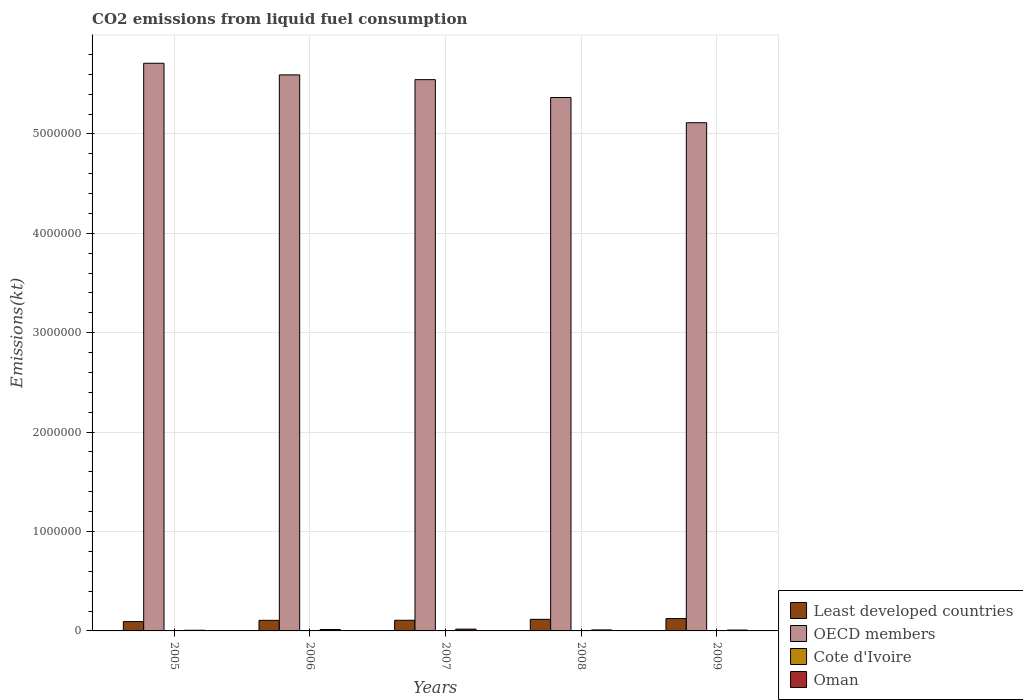How many different coloured bars are there?
Ensure brevity in your answer.  4. How many groups of bars are there?
Your answer should be very brief. 5. How many bars are there on the 4th tick from the left?
Your answer should be very brief. 4. What is the label of the 2nd group of bars from the left?
Give a very brief answer. 2006. What is the amount of CO2 emitted in OECD members in 2009?
Your answer should be very brief. 5.11e+06. Across all years, what is the maximum amount of CO2 emitted in Least developed countries?
Provide a short and direct response. 1.24e+05. Across all years, what is the minimum amount of CO2 emitted in OECD members?
Provide a succinct answer. 5.11e+06. In which year was the amount of CO2 emitted in OECD members maximum?
Provide a succinct answer. 2005. What is the total amount of CO2 emitted in Cote d'Ivoire in the graph?
Provide a short and direct response. 1.82e+04. What is the difference between the amount of CO2 emitted in Cote d'Ivoire in 2005 and that in 2008?
Your answer should be compact. 517.05. What is the difference between the amount of CO2 emitted in Cote d'Ivoire in 2008 and the amount of CO2 emitted in Least developed countries in 2009?
Offer a terse response. -1.20e+05. What is the average amount of CO2 emitted in Least developed countries per year?
Your answer should be compact. 1.10e+05. In the year 2005, what is the difference between the amount of CO2 emitted in Cote d'Ivoire and amount of CO2 emitted in OECD members?
Offer a very short reply. -5.71e+06. In how many years, is the amount of CO2 emitted in Least developed countries greater than 4400000 kt?
Ensure brevity in your answer.  0. What is the ratio of the amount of CO2 emitted in OECD members in 2008 to that in 2009?
Give a very brief answer. 1.05. What is the difference between the highest and the second highest amount of CO2 emitted in Oman?
Give a very brief answer. 4176.71. What is the difference between the highest and the lowest amount of CO2 emitted in Least developed countries?
Offer a very short reply. 3.02e+04. In how many years, is the amount of CO2 emitted in Oman greater than the average amount of CO2 emitted in Oman taken over all years?
Provide a short and direct response. 2. What does the 3rd bar from the left in 2009 represents?
Provide a succinct answer. Cote d'Ivoire. What does the 3rd bar from the right in 2005 represents?
Make the answer very short. OECD members. Are all the bars in the graph horizontal?
Your response must be concise. No. What is the difference between two consecutive major ticks on the Y-axis?
Offer a terse response. 1.00e+06. Are the values on the major ticks of Y-axis written in scientific E-notation?
Provide a short and direct response. No. Where does the legend appear in the graph?
Your answer should be compact. Bottom right. What is the title of the graph?
Keep it short and to the point. CO2 emissions from liquid fuel consumption. Does "Togo" appear as one of the legend labels in the graph?
Keep it short and to the point. No. What is the label or title of the Y-axis?
Provide a short and direct response. Emissions(kt). What is the Emissions(kt) in Least developed countries in 2005?
Provide a succinct answer. 9.39e+04. What is the Emissions(kt) in OECD members in 2005?
Provide a short and direct response. 5.71e+06. What is the Emissions(kt) of Cote d'Ivoire in 2005?
Provide a short and direct response. 4165.71. What is the Emissions(kt) in Oman in 2005?
Your response must be concise. 6875.62. What is the Emissions(kt) in Least developed countries in 2006?
Your response must be concise. 1.06e+05. What is the Emissions(kt) of OECD members in 2006?
Give a very brief answer. 5.59e+06. What is the Emissions(kt) of Cote d'Ivoire in 2006?
Your answer should be compact. 3681.67. What is the Emissions(kt) of Oman in 2006?
Make the answer very short. 1.40e+04. What is the Emissions(kt) of Least developed countries in 2007?
Your answer should be very brief. 1.07e+05. What is the Emissions(kt) in OECD members in 2007?
Provide a short and direct response. 5.55e+06. What is the Emissions(kt) in Cote d'Ivoire in 2007?
Your response must be concise. 3758.68. What is the Emissions(kt) of Oman in 2007?
Make the answer very short. 1.82e+04. What is the Emissions(kt) in Least developed countries in 2008?
Give a very brief answer. 1.16e+05. What is the Emissions(kt) of OECD members in 2008?
Provide a short and direct response. 5.37e+06. What is the Emissions(kt) in Cote d'Ivoire in 2008?
Provide a short and direct response. 3648.66. What is the Emissions(kt) in Oman in 2008?
Provide a succinct answer. 9933.9. What is the Emissions(kt) of Least developed countries in 2009?
Provide a succinct answer. 1.24e+05. What is the Emissions(kt) of OECD members in 2009?
Make the answer very short. 5.11e+06. What is the Emissions(kt) in Cote d'Ivoire in 2009?
Your answer should be very brief. 2929.93. What is the Emissions(kt) in Oman in 2009?
Provide a short and direct response. 8742.13. Across all years, what is the maximum Emissions(kt) in Least developed countries?
Ensure brevity in your answer.  1.24e+05. Across all years, what is the maximum Emissions(kt) of OECD members?
Keep it short and to the point. 5.71e+06. Across all years, what is the maximum Emissions(kt) in Cote d'Ivoire?
Ensure brevity in your answer.  4165.71. Across all years, what is the maximum Emissions(kt) in Oman?
Give a very brief answer. 1.82e+04. Across all years, what is the minimum Emissions(kt) in Least developed countries?
Give a very brief answer. 9.39e+04. Across all years, what is the minimum Emissions(kt) of OECD members?
Your answer should be compact. 5.11e+06. Across all years, what is the minimum Emissions(kt) of Cote d'Ivoire?
Give a very brief answer. 2929.93. Across all years, what is the minimum Emissions(kt) of Oman?
Ensure brevity in your answer.  6875.62. What is the total Emissions(kt) of Least developed countries in the graph?
Give a very brief answer. 5.48e+05. What is the total Emissions(kt) in OECD members in the graph?
Offer a very short reply. 2.73e+07. What is the total Emissions(kt) in Cote d'Ivoire in the graph?
Your answer should be compact. 1.82e+04. What is the total Emissions(kt) in Oman in the graph?
Make the answer very short. 5.78e+04. What is the difference between the Emissions(kt) in Least developed countries in 2005 and that in 2006?
Provide a short and direct response. -1.26e+04. What is the difference between the Emissions(kt) in OECD members in 2005 and that in 2006?
Provide a short and direct response. 1.17e+05. What is the difference between the Emissions(kt) of Cote d'Ivoire in 2005 and that in 2006?
Make the answer very short. 484.04. What is the difference between the Emissions(kt) of Oman in 2005 and that in 2006?
Your answer should be very brief. -7165.32. What is the difference between the Emissions(kt) in Least developed countries in 2005 and that in 2007?
Provide a short and direct response. -1.33e+04. What is the difference between the Emissions(kt) in OECD members in 2005 and that in 2007?
Make the answer very short. 1.65e+05. What is the difference between the Emissions(kt) of Cote d'Ivoire in 2005 and that in 2007?
Offer a very short reply. 407.04. What is the difference between the Emissions(kt) in Oman in 2005 and that in 2007?
Your answer should be very brief. -1.13e+04. What is the difference between the Emissions(kt) in Least developed countries in 2005 and that in 2008?
Offer a very short reply. -2.26e+04. What is the difference between the Emissions(kt) of OECD members in 2005 and that in 2008?
Ensure brevity in your answer.  3.45e+05. What is the difference between the Emissions(kt) of Cote d'Ivoire in 2005 and that in 2008?
Provide a succinct answer. 517.05. What is the difference between the Emissions(kt) of Oman in 2005 and that in 2008?
Provide a short and direct response. -3058.28. What is the difference between the Emissions(kt) in Least developed countries in 2005 and that in 2009?
Offer a very short reply. -3.02e+04. What is the difference between the Emissions(kt) in OECD members in 2005 and that in 2009?
Your answer should be very brief. 5.98e+05. What is the difference between the Emissions(kt) in Cote d'Ivoire in 2005 and that in 2009?
Provide a short and direct response. 1235.78. What is the difference between the Emissions(kt) in Oman in 2005 and that in 2009?
Provide a short and direct response. -1866.5. What is the difference between the Emissions(kt) in Least developed countries in 2006 and that in 2007?
Give a very brief answer. -741.75. What is the difference between the Emissions(kt) of OECD members in 2006 and that in 2007?
Provide a succinct answer. 4.79e+04. What is the difference between the Emissions(kt) of Cote d'Ivoire in 2006 and that in 2007?
Offer a terse response. -77.01. What is the difference between the Emissions(kt) of Oman in 2006 and that in 2007?
Offer a terse response. -4176.71. What is the difference between the Emissions(kt) in Least developed countries in 2006 and that in 2008?
Offer a very short reply. -1.00e+04. What is the difference between the Emissions(kt) in OECD members in 2006 and that in 2008?
Keep it short and to the point. 2.28e+05. What is the difference between the Emissions(kt) of Cote d'Ivoire in 2006 and that in 2008?
Provide a succinct answer. 33. What is the difference between the Emissions(kt) in Oman in 2006 and that in 2008?
Give a very brief answer. 4107.04. What is the difference between the Emissions(kt) of Least developed countries in 2006 and that in 2009?
Offer a terse response. -1.76e+04. What is the difference between the Emissions(kt) in OECD members in 2006 and that in 2009?
Your response must be concise. 4.81e+05. What is the difference between the Emissions(kt) of Cote d'Ivoire in 2006 and that in 2009?
Offer a very short reply. 751.74. What is the difference between the Emissions(kt) in Oman in 2006 and that in 2009?
Offer a terse response. 5298.81. What is the difference between the Emissions(kt) in Least developed countries in 2007 and that in 2008?
Your answer should be very brief. -9295.17. What is the difference between the Emissions(kt) of OECD members in 2007 and that in 2008?
Keep it short and to the point. 1.80e+05. What is the difference between the Emissions(kt) of Cote d'Ivoire in 2007 and that in 2008?
Make the answer very short. 110.01. What is the difference between the Emissions(kt) of Oman in 2007 and that in 2008?
Your answer should be compact. 8283.75. What is the difference between the Emissions(kt) in Least developed countries in 2007 and that in 2009?
Offer a terse response. -1.69e+04. What is the difference between the Emissions(kt) of OECD members in 2007 and that in 2009?
Your answer should be very brief. 4.33e+05. What is the difference between the Emissions(kt) in Cote d'Ivoire in 2007 and that in 2009?
Your response must be concise. 828.74. What is the difference between the Emissions(kt) of Oman in 2007 and that in 2009?
Provide a short and direct response. 9475.53. What is the difference between the Emissions(kt) in Least developed countries in 2008 and that in 2009?
Provide a succinct answer. -7571.93. What is the difference between the Emissions(kt) of OECD members in 2008 and that in 2009?
Your response must be concise. 2.54e+05. What is the difference between the Emissions(kt) in Cote d'Ivoire in 2008 and that in 2009?
Give a very brief answer. 718.73. What is the difference between the Emissions(kt) of Oman in 2008 and that in 2009?
Your response must be concise. 1191.78. What is the difference between the Emissions(kt) in Least developed countries in 2005 and the Emissions(kt) in OECD members in 2006?
Offer a terse response. -5.50e+06. What is the difference between the Emissions(kt) of Least developed countries in 2005 and the Emissions(kt) of Cote d'Ivoire in 2006?
Your response must be concise. 9.02e+04. What is the difference between the Emissions(kt) in Least developed countries in 2005 and the Emissions(kt) in Oman in 2006?
Your answer should be compact. 7.98e+04. What is the difference between the Emissions(kt) of OECD members in 2005 and the Emissions(kt) of Cote d'Ivoire in 2006?
Keep it short and to the point. 5.71e+06. What is the difference between the Emissions(kt) of OECD members in 2005 and the Emissions(kt) of Oman in 2006?
Provide a short and direct response. 5.70e+06. What is the difference between the Emissions(kt) of Cote d'Ivoire in 2005 and the Emissions(kt) of Oman in 2006?
Make the answer very short. -9875.23. What is the difference between the Emissions(kt) of Least developed countries in 2005 and the Emissions(kt) of OECD members in 2007?
Provide a short and direct response. -5.45e+06. What is the difference between the Emissions(kt) of Least developed countries in 2005 and the Emissions(kt) of Cote d'Ivoire in 2007?
Your answer should be very brief. 9.01e+04. What is the difference between the Emissions(kt) in Least developed countries in 2005 and the Emissions(kt) in Oman in 2007?
Give a very brief answer. 7.56e+04. What is the difference between the Emissions(kt) in OECD members in 2005 and the Emissions(kt) in Cote d'Ivoire in 2007?
Make the answer very short. 5.71e+06. What is the difference between the Emissions(kt) of OECD members in 2005 and the Emissions(kt) of Oman in 2007?
Make the answer very short. 5.69e+06. What is the difference between the Emissions(kt) of Cote d'Ivoire in 2005 and the Emissions(kt) of Oman in 2007?
Your response must be concise. -1.41e+04. What is the difference between the Emissions(kt) in Least developed countries in 2005 and the Emissions(kt) in OECD members in 2008?
Give a very brief answer. -5.27e+06. What is the difference between the Emissions(kt) in Least developed countries in 2005 and the Emissions(kt) in Cote d'Ivoire in 2008?
Provide a short and direct response. 9.02e+04. What is the difference between the Emissions(kt) of Least developed countries in 2005 and the Emissions(kt) of Oman in 2008?
Make the answer very short. 8.39e+04. What is the difference between the Emissions(kt) in OECD members in 2005 and the Emissions(kt) in Cote d'Ivoire in 2008?
Make the answer very short. 5.71e+06. What is the difference between the Emissions(kt) in OECD members in 2005 and the Emissions(kt) in Oman in 2008?
Your response must be concise. 5.70e+06. What is the difference between the Emissions(kt) of Cote d'Ivoire in 2005 and the Emissions(kt) of Oman in 2008?
Your response must be concise. -5768.19. What is the difference between the Emissions(kt) in Least developed countries in 2005 and the Emissions(kt) in OECD members in 2009?
Your answer should be very brief. -5.02e+06. What is the difference between the Emissions(kt) in Least developed countries in 2005 and the Emissions(kt) in Cote d'Ivoire in 2009?
Provide a succinct answer. 9.09e+04. What is the difference between the Emissions(kt) of Least developed countries in 2005 and the Emissions(kt) of Oman in 2009?
Your response must be concise. 8.51e+04. What is the difference between the Emissions(kt) of OECD members in 2005 and the Emissions(kt) of Cote d'Ivoire in 2009?
Keep it short and to the point. 5.71e+06. What is the difference between the Emissions(kt) in OECD members in 2005 and the Emissions(kt) in Oman in 2009?
Your response must be concise. 5.70e+06. What is the difference between the Emissions(kt) of Cote d'Ivoire in 2005 and the Emissions(kt) of Oman in 2009?
Provide a short and direct response. -4576.42. What is the difference between the Emissions(kt) in Least developed countries in 2006 and the Emissions(kt) in OECD members in 2007?
Give a very brief answer. -5.44e+06. What is the difference between the Emissions(kt) in Least developed countries in 2006 and the Emissions(kt) in Cote d'Ivoire in 2007?
Make the answer very short. 1.03e+05. What is the difference between the Emissions(kt) in Least developed countries in 2006 and the Emissions(kt) in Oman in 2007?
Offer a very short reply. 8.82e+04. What is the difference between the Emissions(kt) in OECD members in 2006 and the Emissions(kt) in Cote d'Ivoire in 2007?
Ensure brevity in your answer.  5.59e+06. What is the difference between the Emissions(kt) in OECD members in 2006 and the Emissions(kt) in Oman in 2007?
Make the answer very short. 5.58e+06. What is the difference between the Emissions(kt) in Cote d'Ivoire in 2006 and the Emissions(kt) in Oman in 2007?
Your answer should be compact. -1.45e+04. What is the difference between the Emissions(kt) of Least developed countries in 2006 and the Emissions(kt) of OECD members in 2008?
Ensure brevity in your answer.  -5.26e+06. What is the difference between the Emissions(kt) of Least developed countries in 2006 and the Emissions(kt) of Cote d'Ivoire in 2008?
Provide a short and direct response. 1.03e+05. What is the difference between the Emissions(kt) of Least developed countries in 2006 and the Emissions(kt) of Oman in 2008?
Provide a short and direct response. 9.65e+04. What is the difference between the Emissions(kt) in OECD members in 2006 and the Emissions(kt) in Cote d'Ivoire in 2008?
Provide a short and direct response. 5.59e+06. What is the difference between the Emissions(kt) in OECD members in 2006 and the Emissions(kt) in Oman in 2008?
Offer a terse response. 5.58e+06. What is the difference between the Emissions(kt) of Cote d'Ivoire in 2006 and the Emissions(kt) of Oman in 2008?
Provide a succinct answer. -6252.23. What is the difference between the Emissions(kt) in Least developed countries in 2006 and the Emissions(kt) in OECD members in 2009?
Keep it short and to the point. -5.01e+06. What is the difference between the Emissions(kt) in Least developed countries in 2006 and the Emissions(kt) in Cote d'Ivoire in 2009?
Provide a short and direct response. 1.04e+05. What is the difference between the Emissions(kt) of Least developed countries in 2006 and the Emissions(kt) of Oman in 2009?
Give a very brief answer. 9.77e+04. What is the difference between the Emissions(kt) in OECD members in 2006 and the Emissions(kt) in Cote d'Ivoire in 2009?
Your answer should be very brief. 5.59e+06. What is the difference between the Emissions(kt) of OECD members in 2006 and the Emissions(kt) of Oman in 2009?
Provide a succinct answer. 5.58e+06. What is the difference between the Emissions(kt) of Cote d'Ivoire in 2006 and the Emissions(kt) of Oman in 2009?
Your answer should be compact. -5060.46. What is the difference between the Emissions(kt) of Least developed countries in 2007 and the Emissions(kt) of OECD members in 2008?
Offer a terse response. -5.26e+06. What is the difference between the Emissions(kt) in Least developed countries in 2007 and the Emissions(kt) in Cote d'Ivoire in 2008?
Ensure brevity in your answer.  1.04e+05. What is the difference between the Emissions(kt) in Least developed countries in 2007 and the Emissions(kt) in Oman in 2008?
Offer a terse response. 9.73e+04. What is the difference between the Emissions(kt) in OECD members in 2007 and the Emissions(kt) in Cote d'Ivoire in 2008?
Keep it short and to the point. 5.54e+06. What is the difference between the Emissions(kt) of OECD members in 2007 and the Emissions(kt) of Oman in 2008?
Make the answer very short. 5.54e+06. What is the difference between the Emissions(kt) in Cote d'Ivoire in 2007 and the Emissions(kt) in Oman in 2008?
Keep it short and to the point. -6175.23. What is the difference between the Emissions(kt) in Least developed countries in 2007 and the Emissions(kt) in OECD members in 2009?
Your answer should be compact. -5.01e+06. What is the difference between the Emissions(kt) of Least developed countries in 2007 and the Emissions(kt) of Cote d'Ivoire in 2009?
Your response must be concise. 1.04e+05. What is the difference between the Emissions(kt) of Least developed countries in 2007 and the Emissions(kt) of Oman in 2009?
Ensure brevity in your answer.  9.84e+04. What is the difference between the Emissions(kt) of OECD members in 2007 and the Emissions(kt) of Cote d'Ivoire in 2009?
Ensure brevity in your answer.  5.54e+06. What is the difference between the Emissions(kt) in OECD members in 2007 and the Emissions(kt) in Oman in 2009?
Ensure brevity in your answer.  5.54e+06. What is the difference between the Emissions(kt) of Cote d'Ivoire in 2007 and the Emissions(kt) of Oman in 2009?
Give a very brief answer. -4983.45. What is the difference between the Emissions(kt) of Least developed countries in 2008 and the Emissions(kt) of OECD members in 2009?
Make the answer very short. -5.00e+06. What is the difference between the Emissions(kt) of Least developed countries in 2008 and the Emissions(kt) of Cote d'Ivoire in 2009?
Your response must be concise. 1.14e+05. What is the difference between the Emissions(kt) of Least developed countries in 2008 and the Emissions(kt) of Oman in 2009?
Your answer should be very brief. 1.08e+05. What is the difference between the Emissions(kt) in OECD members in 2008 and the Emissions(kt) in Cote d'Ivoire in 2009?
Offer a terse response. 5.36e+06. What is the difference between the Emissions(kt) of OECD members in 2008 and the Emissions(kt) of Oman in 2009?
Your response must be concise. 5.36e+06. What is the difference between the Emissions(kt) of Cote d'Ivoire in 2008 and the Emissions(kt) of Oman in 2009?
Offer a terse response. -5093.46. What is the average Emissions(kt) of Least developed countries per year?
Your response must be concise. 1.10e+05. What is the average Emissions(kt) in OECD members per year?
Give a very brief answer. 5.47e+06. What is the average Emissions(kt) in Cote d'Ivoire per year?
Your answer should be compact. 3636.93. What is the average Emissions(kt) in Oman per year?
Provide a succinct answer. 1.16e+04. In the year 2005, what is the difference between the Emissions(kt) of Least developed countries and Emissions(kt) of OECD members?
Offer a very short reply. -5.62e+06. In the year 2005, what is the difference between the Emissions(kt) in Least developed countries and Emissions(kt) in Cote d'Ivoire?
Provide a succinct answer. 8.97e+04. In the year 2005, what is the difference between the Emissions(kt) in Least developed countries and Emissions(kt) in Oman?
Provide a short and direct response. 8.70e+04. In the year 2005, what is the difference between the Emissions(kt) in OECD members and Emissions(kt) in Cote d'Ivoire?
Offer a very short reply. 5.71e+06. In the year 2005, what is the difference between the Emissions(kt) in OECD members and Emissions(kt) in Oman?
Provide a succinct answer. 5.70e+06. In the year 2005, what is the difference between the Emissions(kt) in Cote d'Ivoire and Emissions(kt) in Oman?
Your response must be concise. -2709.91. In the year 2006, what is the difference between the Emissions(kt) in Least developed countries and Emissions(kt) in OECD members?
Keep it short and to the point. -5.49e+06. In the year 2006, what is the difference between the Emissions(kt) in Least developed countries and Emissions(kt) in Cote d'Ivoire?
Provide a short and direct response. 1.03e+05. In the year 2006, what is the difference between the Emissions(kt) in Least developed countries and Emissions(kt) in Oman?
Ensure brevity in your answer.  9.24e+04. In the year 2006, what is the difference between the Emissions(kt) of OECD members and Emissions(kt) of Cote d'Ivoire?
Offer a terse response. 5.59e+06. In the year 2006, what is the difference between the Emissions(kt) in OECD members and Emissions(kt) in Oman?
Make the answer very short. 5.58e+06. In the year 2006, what is the difference between the Emissions(kt) in Cote d'Ivoire and Emissions(kt) in Oman?
Your answer should be compact. -1.04e+04. In the year 2007, what is the difference between the Emissions(kt) of Least developed countries and Emissions(kt) of OECD members?
Your answer should be very brief. -5.44e+06. In the year 2007, what is the difference between the Emissions(kt) of Least developed countries and Emissions(kt) of Cote d'Ivoire?
Provide a succinct answer. 1.03e+05. In the year 2007, what is the difference between the Emissions(kt) in Least developed countries and Emissions(kt) in Oman?
Ensure brevity in your answer.  8.90e+04. In the year 2007, what is the difference between the Emissions(kt) in OECD members and Emissions(kt) in Cote d'Ivoire?
Give a very brief answer. 5.54e+06. In the year 2007, what is the difference between the Emissions(kt) in OECD members and Emissions(kt) in Oman?
Offer a terse response. 5.53e+06. In the year 2007, what is the difference between the Emissions(kt) in Cote d'Ivoire and Emissions(kt) in Oman?
Make the answer very short. -1.45e+04. In the year 2008, what is the difference between the Emissions(kt) in Least developed countries and Emissions(kt) in OECD members?
Give a very brief answer. -5.25e+06. In the year 2008, what is the difference between the Emissions(kt) of Least developed countries and Emissions(kt) of Cote d'Ivoire?
Offer a very short reply. 1.13e+05. In the year 2008, what is the difference between the Emissions(kt) of Least developed countries and Emissions(kt) of Oman?
Provide a short and direct response. 1.07e+05. In the year 2008, what is the difference between the Emissions(kt) of OECD members and Emissions(kt) of Cote d'Ivoire?
Your answer should be very brief. 5.36e+06. In the year 2008, what is the difference between the Emissions(kt) in OECD members and Emissions(kt) in Oman?
Keep it short and to the point. 5.36e+06. In the year 2008, what is the difference between the Emissions(kt) in Cote d'Ivoire and Emissions(kt) in Oman?
Offer a terse response. -6285.24. In the year 2009, what is the difference between the Emissions(kt) in Least developed countries and Emissions(kt) in OECD members?
Keep it short and to the point. -4.99e+06. In the year 2009, what is the difference between the Emissions(kt) of Least developed countries and Emissions(kt) of Cote d'Ivoire?
Keep it short and to the point. 1.21e+05. In the year 2009, what is the difference between the Emissions(kt) in Least developed countries and Emissions(kt) in Oman?
Ensure brevity in your answer.  1.15e+05. In the year 2009, what is the difference between the Emissions(kt) in OECD members and Emissions(kt) in Cote d'Ivoire?
Your answer should be very brief. 5.11e+06. In the year 2009, what is the difference between the Emissions(kt) of OECD members and Emissions(kt) of Oman?
Make the answer very short. 5.10e+06. In the year 2009, what is the difference between the Emissions(kt) in Cote d'Ivoire and Emissions(kt) in Oman?
Give a very brief answer. -5812.19. What is the ratio of the Emissions(kt) of Least developed countries in 2005 to that in 2006?
Offer a very short reply. 0.88. What is the ratio of the Emissions(kt) of OECD members in 2005 to that in 2006?
Provide a short and direct response. 1.02. What is the ratio of the Emissions(kt) of Cote d'Ivoire in 2005 to that in 2006?
Your response must be concise. 1.13. What is the ratio of the Emissions(kt) in Oman in 2005 to that in 2006?
Your answer should be very brief. 0.49. What is the ratio of the Emissions(kt) in Least developed countries in 2005 to that in 2007?
Your response must be concise. 0.88. What is the ratio of the Emissions(kt) in OECD members in 2005 to that in 2007?
Make the answer very short. 1.03. What is the ratio of the Emissions(kt) in Cote d'Ivoire in 2005 to that in 2007?
Offer a terse response. 1.11. What is the ratio of the Emissions(kt) of Oman in 2005 to that in 2007?
Provide a short and direct response. 0.38. What is the ratio of the Emissions(kt) of Least developed countries in 2005 to that in 2008?
Provide a succinct answer. 0.81. What is the ratio of the Emissions(kt) of OECD members in 2005 to that in 2008?
Offer a terse response. 1.06. What is the ratio of the Emissions(kt) of Cote d'Ivoire in 2005 to that in 2008?
Ensure brevity in your answer.  1.14. What is the ratio of the Emissions(kt) in Oman in 2005 to that in 2008?
Give a very brief answer. 0.69. What is the ratio of the Emissions(kt) in Least developed countries in 2005 to that in 2009?
Your answer should be very brief. 0.76. What is the ratio of the Emissions(kt) of OECD members in 2005 to that in 2009?
Provide a short and direct response. 1.12. What is the ratio of the Emissions(kt) in Cote d'Ivoire in 2005 to that in 2009?
Ensure brevity in your answer.  1.42. What is the ratio of the Emissions(kt) in Oman in 2005 to that in 2009?
Your answer should be very brief. 0.79. What is the ratio of the Emissions(kt) in OECD members in 2006 to that in 2007?
Give a very brief answer. 1.01. What is the ratio of the Emissions(kt) in Cote d'Ivoire in 2006 to that in 2007?
Give a very brief answer. 0.98. What is the ratio of the Emissions(kt) of Oman in 2006 to that in 2007?
Offer a terse response. 0.77. What is the ratio of the Emissions(kt) of Least developed countries in 2006 to that in 2008?
Your answer should be compact. 0.91. What is the ratio of the Emissions(kt) of OECD members in 2006 to that in 2008?
Your answer should be compact. 1.04. What is the ratio of the Emissions(kt) of Cote d'Ivoire in 2006 to that in 2008?
Offer a very short reply. 1.01. What is the ratio of the Emissions(kt) of Oman in 2006 to that in 2008?
Offer a very short reply. 1.41. What is the ratio of the Emissions(kt) of Least developed countries in 2006 to that in 2009?
Keep it short and to the point. 0.86. What is the ratio of the Emissions(kt) of OECD members in 2006 to that in 2009?
Provide a succinct answer. 1.09. What is the ratio of the Emissions(kt) of Cote d'Ivoire in 2006 to that in 2009?
Make the answer very short. 1.26. What is the ratio of the Emissions(kt) in Oman in 2006 to that in 2009?
Provide a short and direct response. 1.61. What is the ratio of the Emissions(kt) in Least developed countries in 2007 to that in 2008?
Give a very brief answer. 0.92. What is the ratio of the Emissions(kt) of OECD members in 2007 to that in 2008?
Provide a short and direct response. 1.03. What is the ratio of the Emissions(kt) of Cote d'Ivoire in 2007 to that in 2008?
Your answer should be very brief. 1.03. What is the ratio of the Emissions(kt) in Oman in 2007 to that in 2008?
Your answer should be compact. 1.83. What is the ratio of the Emissions(kt) in Least developed countries in 2007 to that in 2009?
Offer a very short reply. 0.86. What is the ratio of the Emissions(kt) of OECD members in 2007 to that in 2009?
Offer a terse response. 1.08. What is the ratio of the Emissions(kt) in Cote d'Ivoire in 2007 to that in 2009?
Provide a succinct answer. 1.28. What is the ratio of the Emissions(kt) of Oman in 2007 to that in 2009?
Your answer should be very brief. 2.08. What is the ratio of the Emissions(kt) in Least developed countries in 2008 to that in 2009?
Your answer should be very brief. 0.94. What is the ratio of the Emissions(kt) of OECD members in 2008 to that in 2009?
Keep it short and to the point. 1.05. What is the ratio of the Emissions(kt) in Cote d'Ivoire in 2008 to that in 2009?
Offer a terse response. 1.25. What is the ratio of the Emissions(kt) of Oman in 2008 to that in 2009?
Offer a terse response. 1.14. What is the difference between the highest and the second highest Emissions(kt) in Least developed countries?
Ensure brevity in your answer.  7571.93. What is the difference between the highest and the second highest Emissions(kt) of OECD members?
Your answer should be very brief. 1.17e+05. What is the difference between the highest and the second highest Emissions(kt) in Cote d'Ivoire?
Ensure brevity in your answer.  407.04. What is the difference between the highest and the second highest Emissions(kt) in Oman?
Your response must be concise. 4176.71. What is the difference between the highest and the lowest Emissions(kt) in Least developed countries?
Offer a very short reply. 3.02e+04. What is the difference between the highest and the lowest Emissions(kt) in OECD members?
Give a very brief answer. 5.98e+05. What is the difference between the highest and the lowest Emissions(kt) in Cote d'Ivoire?
Offer a very short reply. 1235.78. What is the difference between the highest and the lowest Emissions(kt) in Oman?
Provide a succinct answer. 1.13e+04. 